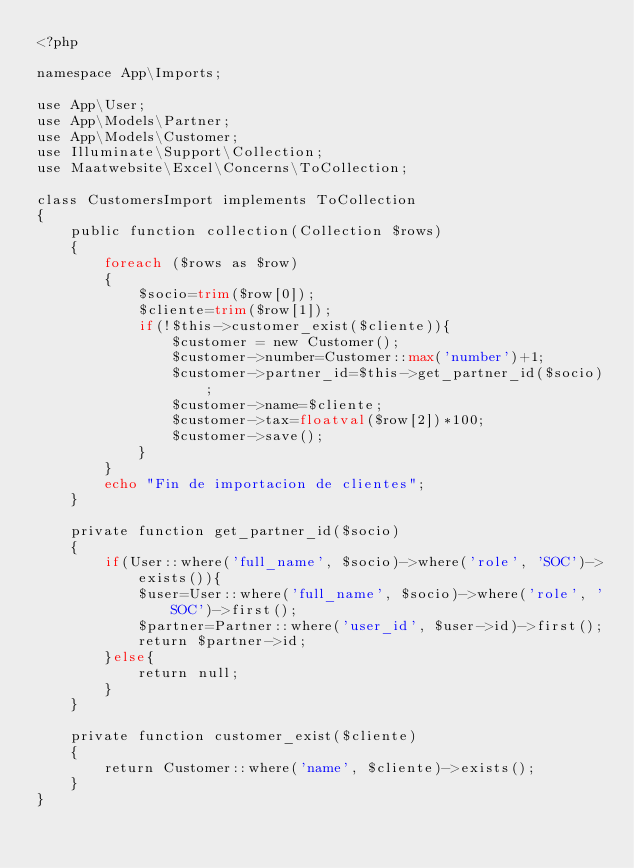Convert code to text. <code><loc_0><loc_0><loc_500><loc_500><_PHP_><?php

namespace App\Imports;

use App\User;
use App\Models\Partner;
use App\Models\Customer;
use Illuminate\Support\Collection;
use Maatwebsite\Excel\Concerns\ToCollection;

class CustomersImport implements ToCollection
{
    public function collection(Collection $rows)
    {
        foreach ($rows as $row) 
        {
            $socio=trim($row[0]);
            $cliente=trim($row[1]);
            if(!$this->customer_exist($cliente)){
                $customer = new Customer();
                $customer->number=Customer::max('number')+1;
                $customer->partner_id=$this->get_partner_id($socio);
                $customer->name=$cliente;
                $customer->tax=floatval($row[2])*100;
                $customer->save();
            }
        }
        echo "Fin de importacion de clientes";
    }

    private function get_partner_id($socio)
    {
        if(User::where('full_name', $socio)->where('role', 'SOC')->exists()){
            $user=User::where('full_name', $socio)->where('role', 'SOC')->first();
            $partner=Partner::where('user_id', $user->id)->first();
            return $partner->id;
        }else{
            return null;
        }
    }

    private function customer_exist($cliente)
    {
        return Customer::where('name', $cliente)->exists();
    }
}</code> 